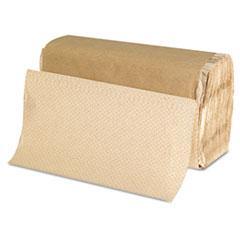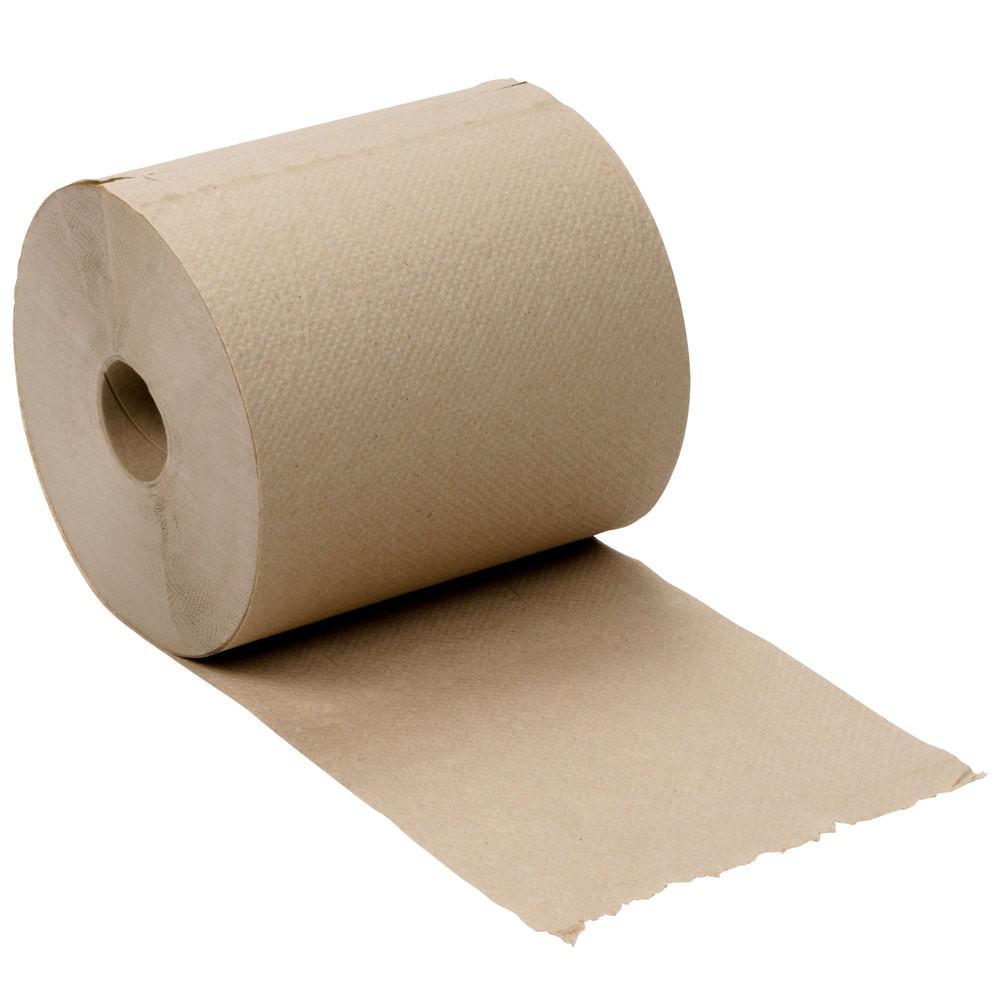The first image is the image on the left, the second image is the image on the right. Evaluate the accuracy of this statement regarding the images: "The image to the right features brown squares of paper towels.". Is it true? Answer yes or no. No. The first image is the image on the left, the second image is the image on the right. Analyze the images presented: Is the assertion "the right pic has a stack of tissues without holder" valid? Answer yes or no. No. 